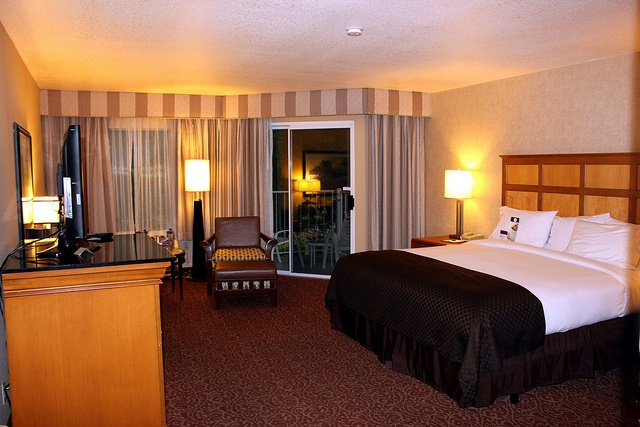Describe the objects in this image and their specific colors. I can see bed in tan, black, pink, lavender, and red tones, couch in tan, black, maroon, and brown tones, chair in tan, black, maroon, and brown tones, tv in tan, black, gray, and lavender tones, and tv in tan, black, brown, ivory, and orange tones in this image. 